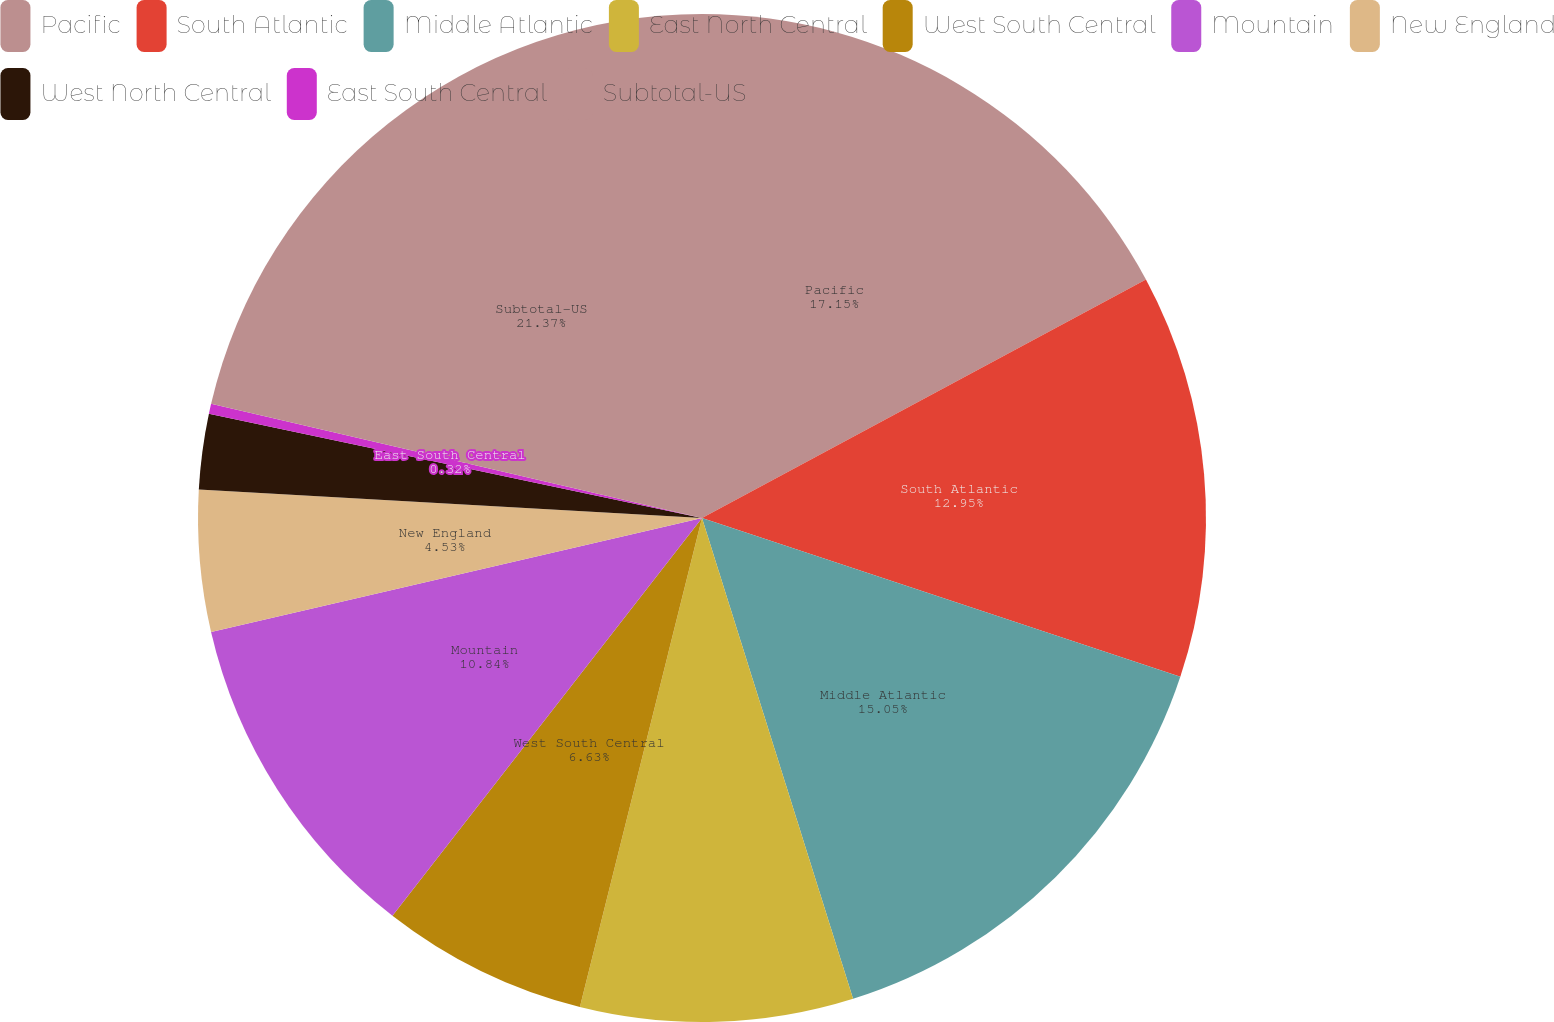<chart> <loc_0><loc_0><loc_500><loc_500><pie_chart><fcel>Pacific<fcel>South Atlantic<fcel>Middle Atlantic<fcel>East North Central<fcel>West South Central<fcel>Mountain<fcel>New England<fcel>West North Central<fcel>East South Central<fcel>Subtotal-US<nl><fcel>17.15%<fcel>12.95%<fcel>15.05%<fcel>8.74%<fcel>6.63%<fcel>10.84%<fcel>4.53%<fcel>2.42%<fcel>0.32%<fcel>21.36%<nl></chart> 